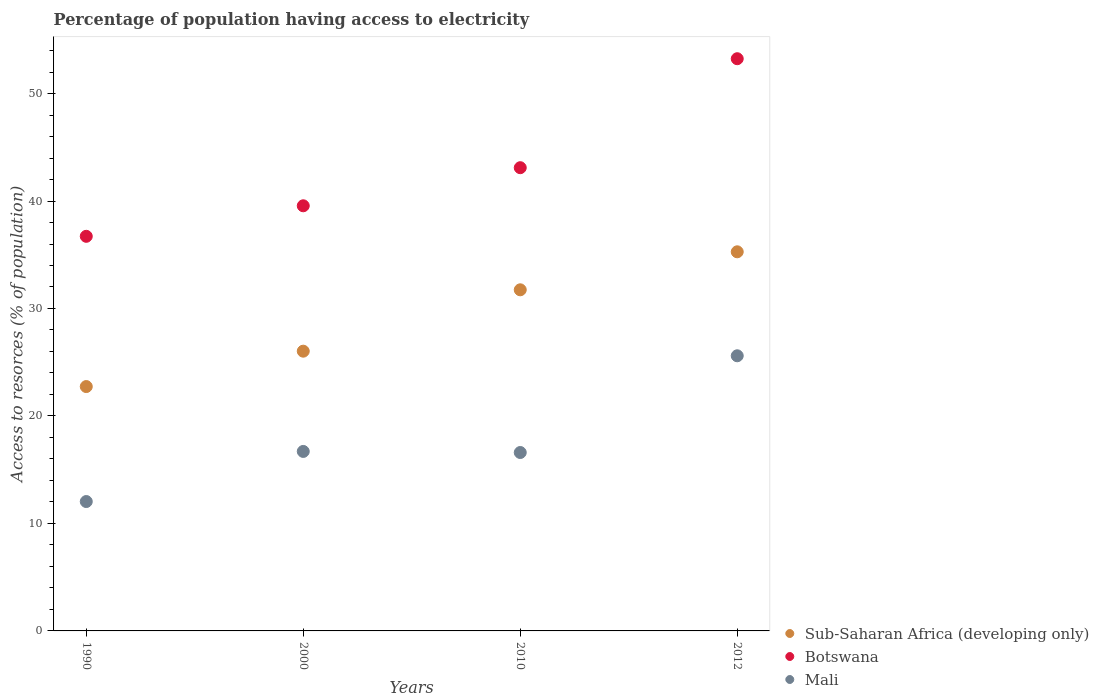Is the number of dotlines equal to the number of legend labels?
Provide a short and direct response. Yes. What is the percentage of population having access to electricity in Botswana in 2000?
Keep it short and to the point. 39.56. Across all years, what is the maximum percentage of population having access to electricity in Sub-Saharan Africa (developing only)?
Give a very brief answer. 35.27. Across all years, what is the minimum percentage of population having access to electricity in Sub-Saharan Africa (developing only)?
Provide a succinct answer. 22.74. In which year was the percentage of population having access to electricity in Mali minimum?
Offer a terse response. 1990. What is the total percentage of population having access to electricity in Mali in the graph?
Your answer should be very brief. 70.94. What is the difference between the percentage of population having access to electricity in Sub-Saharan Africa (developing only) in 1990 and that in 2010?
Ensure brevity in your answer.  -9. What is the difference between the percentage of population having access to electricity in Botswana in 1990 and the percentage of population having access to electricity in Sub-Saharan Africa (developing only) in 2010?
Offer a terse response. 4.98. What is the average percentage of population having access to electricity in Botswana per year?
Offer a terse response. 43.15. In the year 2012, what is the difference between the percentage of population having access to electricity in Mali and percentage of population having access to electricity in Sub-Saharan Africa (developing only)?
Make the answer very short. -9.67. What is the ratio of the percentage of population having access to electricity in Sub-Saharan Africa (developing only) in 2000 to that in 2010?
Your response must be concise. 0.82. Is the percentage of population having access to electricity in Sub-Saharan Africa (developing only) in 2000 less than that in 2010?
Provide a succinct answer. Yes. Is the difference between the percentage of population having access to electricity in Mali in 2000 and 2010 greater than the difference between the percentage of population having access to electricity in Sub-Saharan Africa (developing only) in 2000 and 2010?
Keep it short and to the point. Yes. What is the difference between the highest and the second highest percentage of population having access to electricity in Mali?
Make the answer very short. 8.9. What is the difference between the highest and the lowest percentage of population having access to electricity in Mali?
Provide a short and direct response. 13.56. Is the percentage of population having access to electricity in Mali strictly greater than the percentage of population having access to electricity in Sub-Saharan Africa (developing only) over the years?
Ensure brevity in your answer.  No. How many years are there in the graph?
Provide a short and direct response. 4. Where does the legend appear in the graph?
Offer a very short reply. Bottom right. How are the legend labels stacked?
Your answer should be very brief. Vertical. What is the title of the graph?
Your answer should be compact. Percentage of population having access to electricity. What is the label or title of the Y-axis?
Provide a succinct answer. Access to resorces (% of population). What is the Access to resorces (% of population) in Sub-Saharan Africa (developing only) in 1990?
Your response must be concise. 22.74. What is the Access to resorces (% of population) of Botswana in 1990?
Provide a succinct answer. 36.72. What is the Access to resorces (% of population) in Mali in 1990?
Provide a short and direct response. 12.04. What is the Access to resorces (% of population) in Sub-Saharan Africa (developing only) in 2000?
Provide a succinct answer. 26.03. What is the Access to resorces (% of population) of Botswana in 2000?
Provide a succinct answer. 39.56. What is the Access to resorces (% of population) in Mali in 2000?
Offer a very short reply. 16.7. What is the Access to resorces (% of population) in Sub-Saharan Africa (developing only) in 2010?
Offer a very short reply. 31.74. What is the Access to resorces (% of population) of Botswana in 2010?
Ensure brevity in your answer.  43.1. What is the Access to resorces (% of population) of Mali in 2010?
Provide a succinct answer. 16.6. What is the Access to resorces (% of population) in Sub-Saharan Africa (developing only) in 2012?
Offer a very short reply. 35.27. What is the Access to resorces (% of population) in Botswana in 2012?
Your answer should be very brief. 53.24. What is the Access to resorces (% of population) in Mali in 2012?
Your response must be concise. 25.6. Across all years, what is the maximum Access to resorces (% of population) of Sub-Saharan Africa (developing only)?
Make the answer very short. 35.27. Across all years, what is the maximum Access to resorces (% of population) in Botswana?
Offer a very short reply. 53.24. Across all years, what is the maximum Access to resorces (% of population) of Mali?
Your answer should be compact. 25.6. Across all years, what is the minimum Access to resorces (% of population) of Sub-Saharan Africa (developing only)?
Your response must be concise. 22.74. Across all years, what is the minimum Access to resorces (% of population) of Botswana?
Keep it short and to the point. 36.72. Across all years, what is the minimum Access to resorces (% of population) in Mali?
Keep it short and to the point. 12.04. What is the total Access to resorces (% of population) in Sub-Saharan Africa (developing only) in the graph?
Keep it short and to the point. 115.78. What is the total Access to resorces (% of population) of Botswana in the graph?
Offer a terse response. 172.61. What is the total Access to resorces (% of population) of Mali in the graph?
Your answer should be very brief. 70.94. What is the difference between the Access to resorces (% of population) in Sub-Saharan Africa (developing only) in 1990 and that in 2000?
Ensure brevity in your answer.  -3.29. What is the difference between the Access to resorces (% of population) in Botswana in 1990 and that in 2000?
Give a very brief answer. -2.84. What is the difference between the Access to resorces (% of population) of Mali in 1990 and that in 2000?
Provide a short and direct response. -4.66. What is the difference between the Access to resorces (% of population) of Sub-Saharan Africa (developing only) in 1990 and that in 2010?
Keep it short and to the point. -9. What is the difference between the Access to resorces (% of population) in Botswana in 1990 and that in 2010?
Make the answer very short. -6.38. What is the difference between the Access to resorces (% of population) in Mali in 1990 and that in 2010?
Offer a terse response. -4.56. What is the difference between the Access to resorces (% of population) of Sub-Saharan Africa (developing only) in 1990 and that in 2012?
Offer a very short reply. -12.54. What is the difference between the Access to resorces (% of population) in Botswana in 1990 and that in 2012?
Your answer should be compact. -16.52. What is the difference between the Access to resorces (% of population) in Mali in 1990 and that in 2012?
Ensure brevity in your answer.  -13.56. What is the difference between the Access to resorces (% of population) in Sub-Saharan Africa (developing only) in 2000 and that in 2010?
Ensure brevity in your answer.  -5.71. What is the difference between the Access to resorces (% of population) in Botswana in 2000 and that in 2010?
Ensure brevity in your answer.  -3.54. What is the difference between the Access to resorces (% of population) of Sub-Saharan Africa (developing only) in 2000 and that in 2012?
Offer a very short reply. -9.25. What is the difference between the Access to resorces (% of population) in Botswana in 2000 and that in 2012?
Offer a terse response. -13.68. What is the difference between the Access to resorces (% of population) in Sub-Saharan Africa (developing only) in 2010 and that in 2012?
Offer a very short reply. -3.54. What is the difference between the Access to resorces (% of population) of Botswana in 2010 and that in 2012?
Your response must be concise. -10.14. What is the difference between the Access to resorces (% of population) of Mali in 2010 and that in 2012?
Provide a succinct answer. -9. What is the difference between the Access to resorces (% of population) of Sub-Saharan Africa (developing only) in 1990 and the Access to resorces (% of population) of Botswana in 2000?
Make the answer very short. -16.82. What is the difference between the Access to resorces (% of population) in Sub-Saharan Africa (developing only) in 1990 and the Access to resorces (% of population) in Mali in 2000?
Provide a succinct answer. 6.04. What is the difference between the Access to resorces (% of population) of Botswana in 1990 and the Access to resorces (% of population) of Mali in 2000?
Your answer should be very brief. 20.02. What is the difference between the Access to resorces (% of population) of Sub-Saharan Africa (developing only) in 1990 and the Access to resorces (% of population) of Botswana in 2010?
Ensure brevity in your answer.  -20.36. What is the difference between the Access to resorces (% of population) of Sub-Saharan Africa (developing only) in 1990 and the Access to resorces (% of population) of Mali in 2010?
Your response must be concise. 6.14. What is the difference between the Access to resorces (% of population) of Botswana in 1990 and the Access to resorces (% of population) of Mali in 2010?
Ensure brevity in your answer.  20.12. What is the difference between the Access to resorces (% of population) of Sub-Saharan Africa (developing only) in 1990 and the Access to resorces (% of population) of Botswana in 2012?
Ensure brevity in your answer.  -30.5. What is the difference between the Access to resorces (% of population) in Sub-Saharan Africa (developing only) in 1990 and the Access to resorces (% of population) in Mali in 2012?
Keep it short and to the point. -2.86. What is the difference between the Access to resorces (% of population) of Botswana in 1990 and the Access to resorces (% of population) of Mali in 2012?
Your answer should be compact. 11.12. What is the difference between the Access to resorces (% of population) of Sub-Saharan Africa (developing only) in 2000 and the Access to resorces (% of population) of Botswana in 2010?
Offer a terse response. -17.07. What is the difference between the Access to resorces (% of population) in Sub-Saharan Africa (developing only) in 2000 and the Access to resorces (% of population) in Mali in 2010?
Your answer should be compact. 9.43. What is the difference between the Access to resorces (% of population) of Botswana in 2000 and the Access to resorces (% of population) of Mali in 2010?
Make the answer very short. 22.96. What is the difference between the Access to resorces (% of population) of Sub-Saharan Africa (developing only) in 2000 and the Access to resorces (% of population) of Botswana in 2012?
Ensure brevity in your answer.  -27.21. What is the difference between the Access to resorces (% of population) in Sub-Saharan Africa (developing only) in 2000 and the Access to resorces (% of population) in Mali in 2012?
Keep it short and to the point. 0.43. What is the difference between the Access to resorces (% of population) in Botswana in 2000 and the Access to resorces (% of population) in Mali in 2012?
Keep it short and to the point. 13.96. What is the difference between the Access to resorces (% of population) of Sub-Saharan Africa (developing only) in 2010 and the Access to resorces (% of population) of Botswana in 2012?
Your answer should be compact. -21.5. What is the difference between the Access to resorces (% of population) in Sub-Saharan Africa (developing only) in 2010 and the Access to resorces (% of population) in Mali in 2012?
Offer a very short reply. 6.14. What is the average Access to resorces (% of population) of Sub-Saharan Africa (developing only) per year?
Provide a succinct answer. 28.94. What is the average Access to resorces (% of population) in Botswana per year?
Your response must be concise. 43.15. What is the average Access to resorces (% of population) in Mali per year?
Ensure brevity in your answer.  17.73. In the year 1990, what is the difference between the Access to resorces (% of population) of Sub-Saharan Africa (developing only) and Access to resorces (% of population) of Botswana?
Offer a very short reply. -13.98. In the year 1990, what is the difference between the Access to resorces (% of population) of Sub-Saharan Africa (developing only) and Access to resorces (% of population) of Mali?
Give a very brief answer. 10.7. In the year 1990, what is the difference between the Access to resorces (% of population) in Botswana and Access to resorces (% of population) in Mali?
Provide a succinct answer. 24.68. In the year 2000, what is the difference between the Access to resorces (% of population) of Sub-Saharan Africa (developing only) and Access to resorces (% of population) of Botswana?
Your answer should be compact. -13.53. In the year 2000, what is the difference between the Access to resorces (% of population) of Sub-Saharan Africa (developing only) and Access to resorces (% of population) of Mali?
Make the answer very short. 9.33. In the year 2000, what is the difference between the Access to resorces (% of population) in Botswana and Access to resorces (% of population) in Mali?
Your answer should be compact. 22.86. In the year 2010, what is the difference between the Access to resorces (% of population) of Sub-Saharan Africa (developing only) and Access to resorces (% of population) of Botswana?
Your answer should be compact. -11.36. In the year 2010, what is the difference between the Access to resorces (% of population) of Sub-Saharan Africa (developing only) and Access to resorces (% of population) of Mali?
Your answer should be compact. 15.14. In the year 2010, what is the difference between the Access to resorces (% of population) of Botswana and Access to resorces (% of population) of Mali?
Your response must be concise. 26.5. In the year 2012, what is the difference between the Access to resorces (% of population) of Sub-Saharan Africa (developing only) and Access to resorces (% of population) of Botswana?
Your answer should be very brief. -17.97. In the year 2012, what is the difference between the Access to resorces (% of population) in Sub-Saharan Africa (developing only) and Access to resorces (% of population) in Mali?
Your response must be concise. 9.67. In the year 2012, what is the difference between the Access to resorces (% of population) in Botswana and Access to resorces (% of population) in Mali?
Your answer should be very brief. 27.64. What is the ratio of the Access to resorces (% of population) of Sub-Saharan Africa (developing only) in 1990 to that in 2000?
Provide a succinct answer. 0.87. What is the ratio of the Access to resorces (% of population) in Botswana in 1990 to that in 2000?
Offer a very short reply. 0.93. What is the ratio of the Access to resorces (% of population) in Mali in 1990 to that in 2000?
Your answer should be very brief. 0.72. What is the ratio of the Access to resorces (% of population) in Sub-Saharan Africa (developing only) in 1990 to that in 2010?
Ensure brevity in your answer.  0.72. What is the ratio of the Access to resorces (% of population) in Botswana in 1990 to that in 2010?
Ensure brevity in your answer.  0.85. What is the ratio of the Access to resorces (% of population) of Mali in 1990 to that in 2010?
Your answer should be compact. 0.73. What is the ratio of the Access to resorces (% of population) of Sub-Saharan Africa (developing only) in 1990 to that in 2012?
Offer a very short reply. 0.64. What is the ratio of the Access to resorces (% of population) in Botswana in 1990 to that in 2012?
Make the answer very short. 0.69. What is the ratio of the Access to resorces (% of population) in Mali in 1990 to that in 2012?
Your response must be concise. 0.47. What is the ratio of the Access to resorces (% of population) in Sub-Saharan Africa (developing only) in 2000 to that in 2010?
Offer a very short reply. 0.82. What is the ratio of the Access to resorces (% of population) of Botswana in 2000 to that in 2010?
Make the answer very short. 0.92. What is the ratio of the Access to resorces (% of population) in Sub-Saharan Africa (developing only) in 2000 to that in 2012?
Provide a short and direct response. 0.74. What is the ratio of the Access to resorces (% of population) in Botswana in 2000 to that in 2012?
Offer a very short reply. 0.74. What is the ratio of the Access to resorces (% of population) in Mali in 2000 to that in 2012?
Offer a very short reply. 0.65. What is the ratio of the Access to resorces (% of population) in Sub-Saharan Africa (developing only) in 2010 to that in 2012?
Your response must be concise. 0.9. What is the ratio of the Access to resorces (% of population) of Botswana in 2010 to that in 2012?
Offer a terse response. 0.81. What is the ratio of the Access to resorces (% of population) of Mali in 2010 to that in 2012?
Provide a short and direct response. 0.65. What is the difference between the highest and the second highest Access to resorces (% of population) in Sub-Saharan Africa (developing only)?
Your response must be concise. 3.54. What is the difference between the highest and the second highest Access to resorces (% of population) of Botswana?
Offer a very short reply. 10.14. What is the difference between the highest and the second highest Access to resorces (% of population) of Mali?
Your answer should be compact. 8.9. What is the difference between the highest and the lowest Access to resorces (% of population) of Sub-Saharan Africa (developing only)?
Your response must be concise. 12.54. What is the difference between the highest and the lowest Access to resorces (% of population) of Botswana?
Make the answer very short. 16.52. What is the difference between the highest and the lowest Access to resorces (% of population) in Mali?
Ensure brevity in your answer.  13.56. 